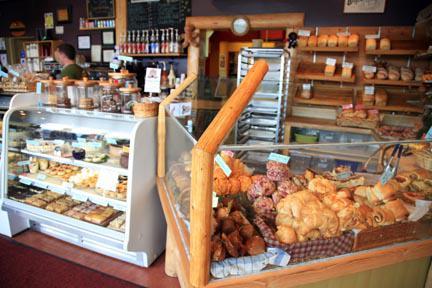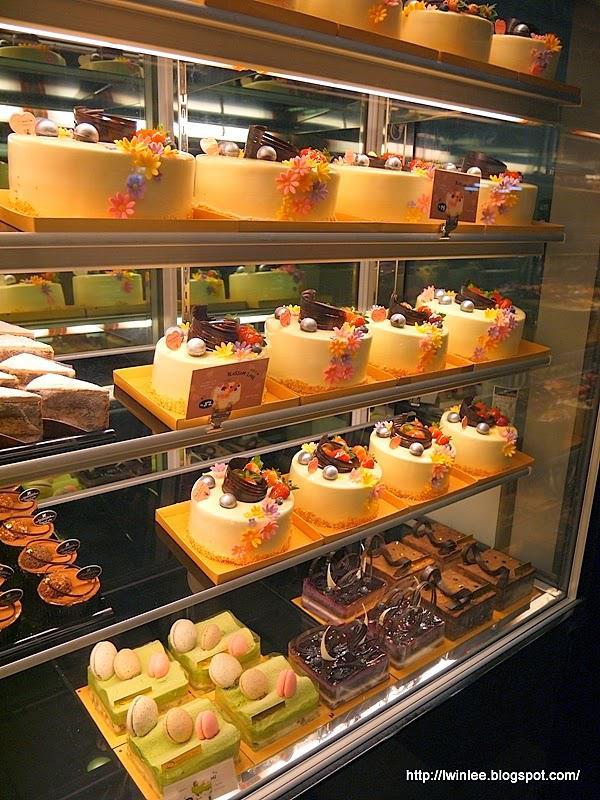The first image is the image on the left, the second image is the image on the right. Assess this claim about the two images: "An image features cakes on pedestal stands under a top tier supported by ornate columns with more cakes on pedestals.". Correct or not? Answer yes or no. No. The first image is the image on the left, the second image is the image on the right. Considering the images on both sides, is "In the image to the right, at least one cake has strawberry on it." valid? Answer yes or no. Yes. 